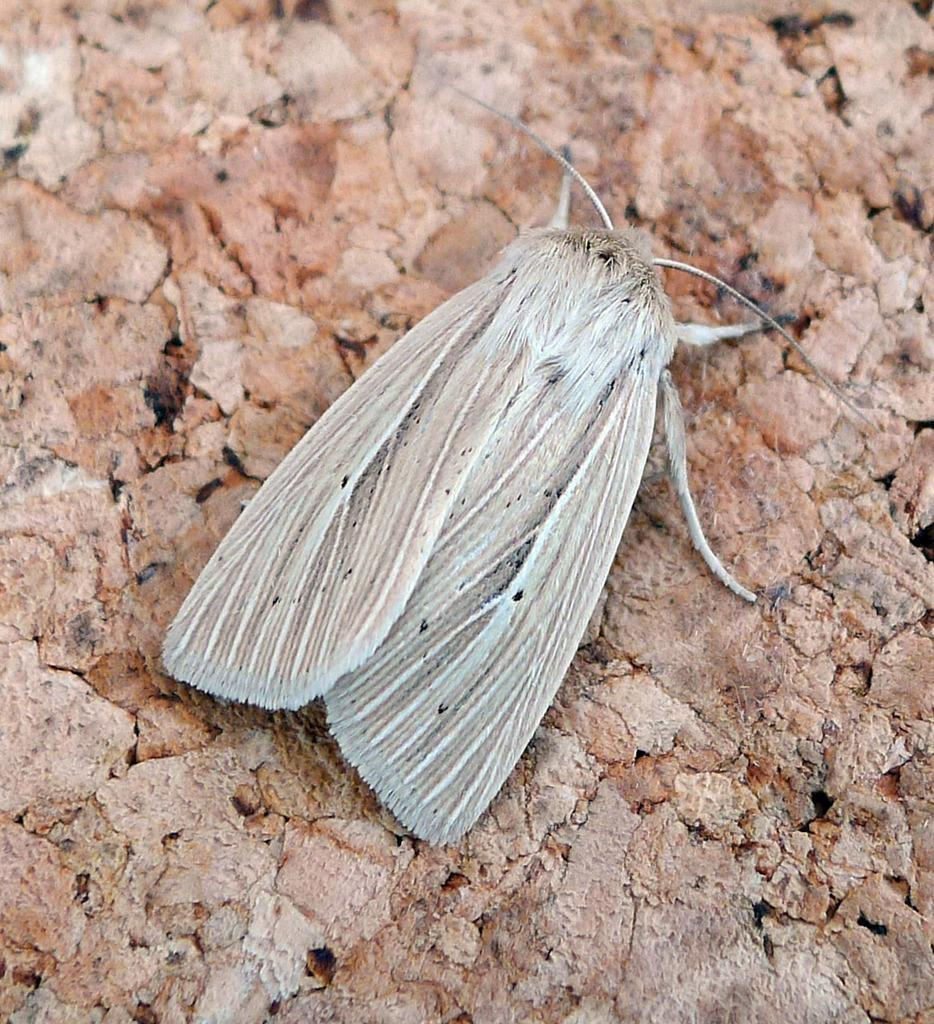What type of creature can be seen in the image? There is an insect in the image. Where is the insect situated? The insect is present on a surface. Can you describe the insect's position in the image? The insect is located in the center of the image. What type of territory does the insect claim in the image? There is no indication of the insect claiming any territory in the image. 